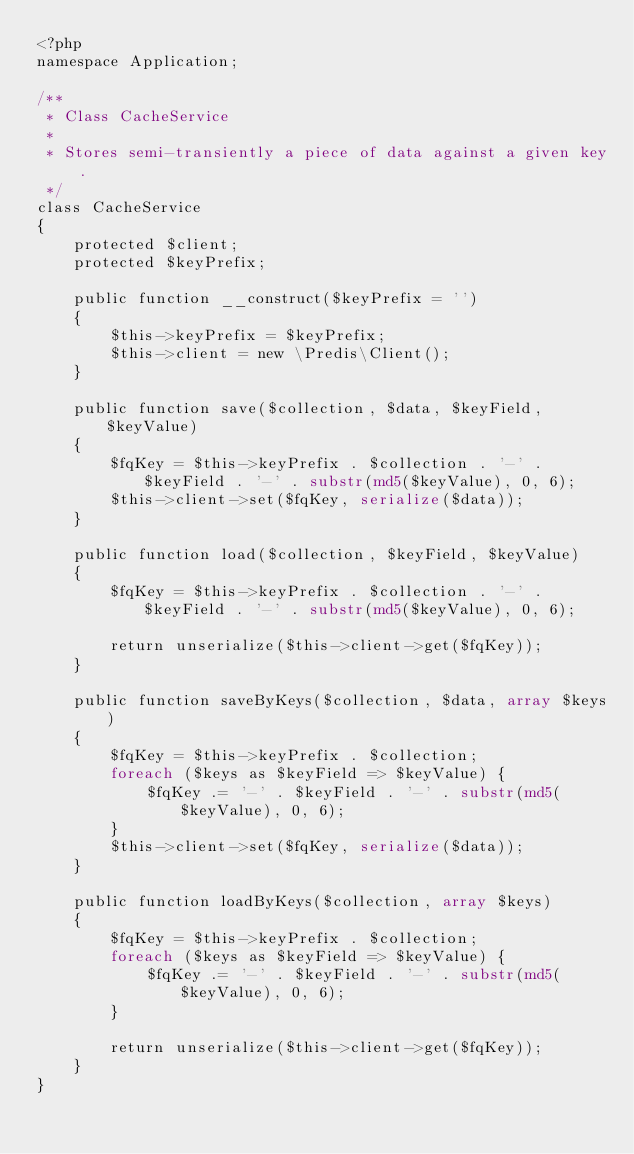Convert code to text. <code><loc_0><loc_0><loc_500><loc_500><_PHP_><?php
namespace Application;

/**
 * Class CacheService
 *
 * Stores semi-transiently a piece of data against a given key.
 */
class CacheService
{
    protected $client;
    protected $keyPrefix;

    public function __construct($keyPrefix = '')
    {
        $this->keyPrefix = $keyPrefix;
        $this->client = new \Predis\Client();
    }

    public function save($collection, $data, $keyField, $keyValue)
    {
        $fqKey = $this->keyPrefix . $collection . '-' . $keyField . '-' . substr(md5($keyValue), 0, 6);
        $this->client->set($fqKey, serialize($data));
    }

    public function load($collection, $keyField, $keyValue)
    {
        $fqKey = $this->keyPrefix . $collection . '-' . $keyField . '-' . substr(md5($keyValue), 0, 6);

        return unserialize($this->client->get($fqKey));
    }

    public function saveByKeys($collection, $data, array $keys)
    {
        $fqKey = $this->keyPrefix . $collection;
        foreach ($keys as $keyField => $keyValue) {
            $fqKey .= '-' . $keyField . '-' . substr(md5($keyValue), 0, 6);
        }
        $this->client->set($fqKey, serialize($data));
    }

    public function loadByKeys($collection, array $keys)
    {
        $fqKey = $this->keyPrefix . $collection;
        foreach ($keys as $keyField => $keyValue) {
            $fqKey .= '-' . $keyField . '-' . substr(md5($keyValue), 0, 6);
        }

        return unserialize($this->client->get($fqKey));
    }
}
</code> 